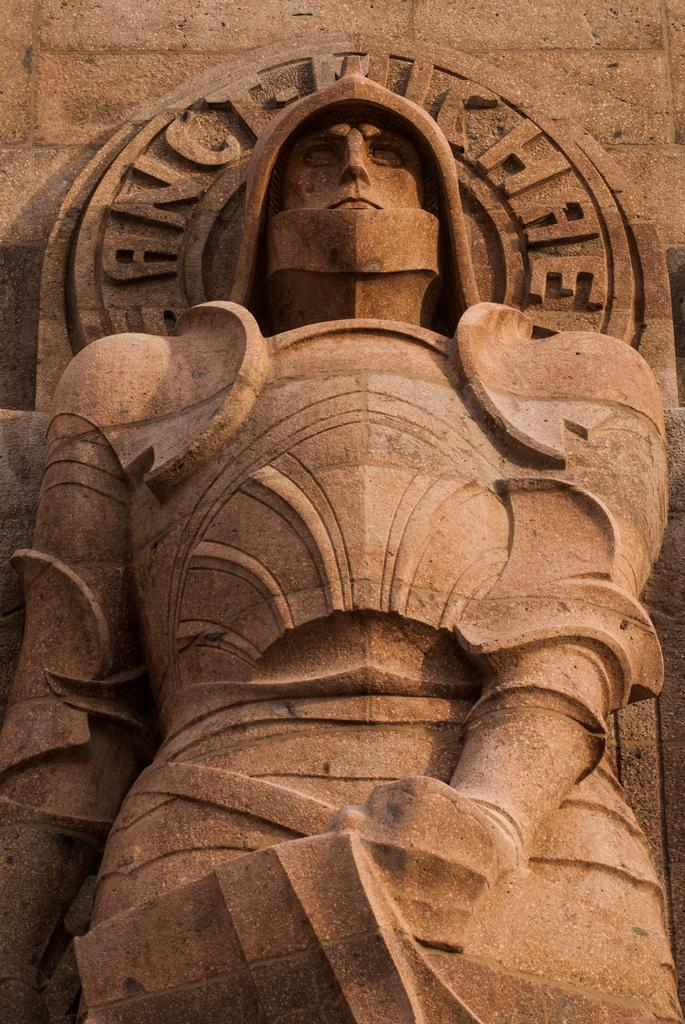What is depicted in the stone carving in the image? There is a stone carving of a person in the image. What else can be seen on the wall in the image? There is text on the wall in the image. What type of owl can be seen in the image? There is no owl present in the image; it features a stone carving of a person and text on the wall. 